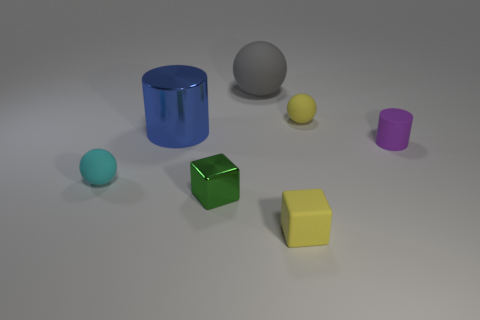There is a large thing that is in front of the gray matte ball; is its shape the same as the large rubber object? No, the shapes are different. The large object in front of the gray matte ball appears to be a cylinder, whereas the large rubber object has a cubical form. 